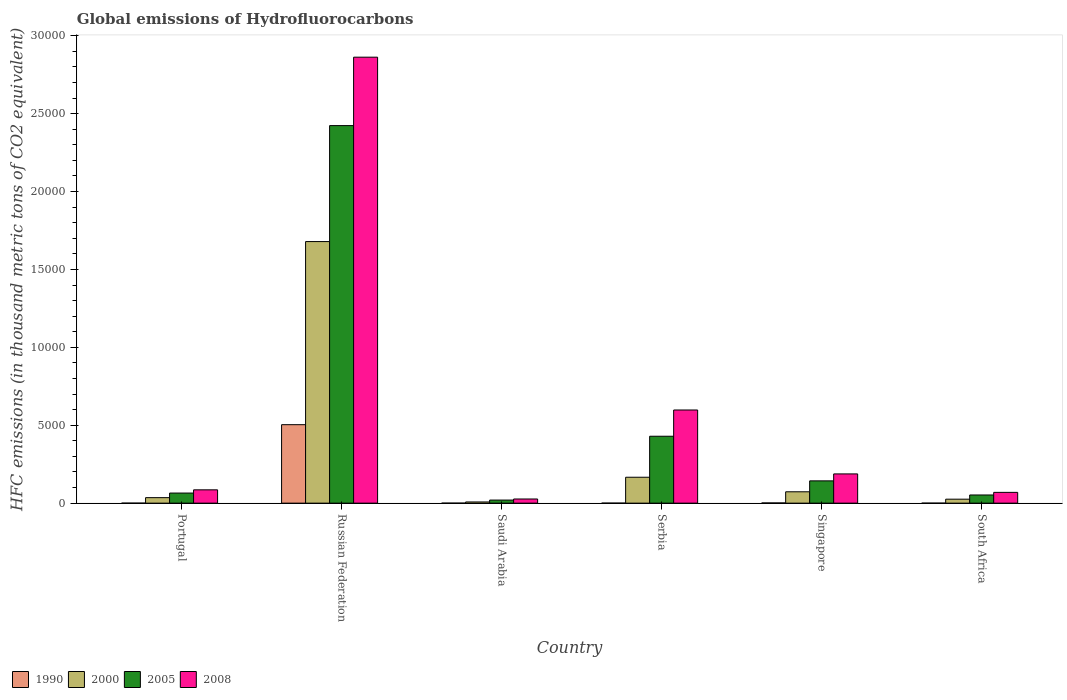Are the number of bars per tick equal to the number of legend labels?
Provide a short and direct response. Yes. How many bars are there on the 6th tick from the right?
Provide a succinct answer. 4. What is the label of the 5th group of bars from the left?
Your response must be concise. Singapore. What is the global emissions of Hydrofluorocarbons in 2000 in Singapore?
Give a very brief answer. 728.9. Across all countries, what is the maximum global emissions of Hydrofluorocarbons in 1990?
Your answer should be compact. 5035.6. Across all countries, what is the minimum global emissions of Hydrofluorocarbons in 2000?
Ensure brevity in your answer.  75.5. In which country was the global emissions of Hydrofluorocarbons in 2005 maximum?
Offer a terse response. Russian Federation. In which country was the global emissions of Hydrofluorocarbons in 2008 minimum?
Make the answer very short. Saudi Arabia. What is the total global emissions of Hydrofluorocarbons in 2000 in the graph?
Your response must be concise. 1.99e+04. What is the difference between the global emissions of Hydrofluorocarbons in 2008 in Portugal and that in Serbia?
Make the answer very short. -5124.6. What is the difference between the global emissions of Hydrofluorocarbons in 1990 in Saudi Arabia and the global emissions of Hydrofluorocarbons in 2000 in Serbia?
Offer a very short reply. -1661.9. What is the average global emissions of Hydrofluorocarbons in 2000 per country?
Ensure brevity in your answer.  3310.4. What is the difference between the global emissions of Hydrofluorocarbons of/in 2005 and global emissions of Hydrofluorocarbons of/in 2000 in Portugal?
Your answer should be very brief. 295. What is the ratio of the global emissions of Hydrofluorocarbons in 2005 in Russian Federation to that in Singapore?
Ensure brevity in your answer.  16.95. Is the difference between the global emissions of Hydrofluorocarbons in 2005 in Saudi Arabia and Serbia greater than the difference between the global emissions of Hydrofluorocarbons in 2000 in Saudi Arabia and Serbia?
Offer a terse response. No. What is the difference between the highest and the second highest global emissions of Hydrofluorocarbons in 2008?
Offer a very short reply. 4102.6. What is the difference between the highest and the lowest global emissions of Hydrofluorocarbons in 2008?
Your response must be concise. 2.84e+04. In how many countries, is the global emissions of Hydrofluorocarbons in 2008 greater than the average global emissions of Hydrofluorocarbons in 2008 taken over all countries?
Your answer should be compact. 1. Is the sum of the global emissions of Hydrofluorocarbons in 2005 in Portugal and Singapore greater than the maximum global emissions of Hydrofluorocarbons in 1990 across all countries?
Provide a short and direct response. No. Is it the case that in every country, the sum of the global emissions of Hydrofluorocarbons in 1990 and global emissions of Hydrofluorocarbons in 2008 is greater than the sum of global emissions of Hydrofluorocarbons in 2005 and global emissions of Hydrofluorocarbons in 2000?
Provide a succinct answer. No. How many bars are there?
Keep it short and to the point. 24. How many countries are there in the graph?
Your response must be concise. 6. What is the difference between two consecutive major ticks on the Y-axis?
Offer a terse response. 5000. How many legend labels are there?
Provide a short and direct response. 4. How are the legend labels stacked?
Keep it short and to the point. Horizontal. What is the title of the graph?
Your answer should be very brief. Global emissions of Hydrofluorocarbons. What is the label or title of the X-axis?
Offer a terse response. Country. What is the label or title of the Y-axis?
Your answer should be compact. HFC emissions (in thousand metric tons of CO2 equivalent). What is the HFC emissions (in thousand metric tons of CO2 equivalent) in 1990 in Portugal?
Offer a very short reply. 0.2. What is the HFC emissions (in thousand metric tons of CO2 equivalent) in 2000 in Portugal?
Keep it short and to the point. 352.7. What is the HFC emissions (in thousand metric tons of CO2 equivalent) in 2005 in Portugal?
Provide a short and direct response. 647.7. What is the HFC emissions (in thousand metric tons of CO2 equivalent) of 2008 in Portugal?
Your response must be concise. 854.4. What is the HFC emissions (in thousand metric tons of CO2 equivalent) in 1990 in Russian Federation?
Offer a terse response. 5035.6. What is the HFC emissions (in thousand metric tons of CO2 equivalent) in 2000 in Russian Federation?
Your response must be concise. 1.68e+04. What is the HFC emissions (in thousand metric tons of CO2 equivalent) in 2005 in Russian Federation?
Your answer should be very brief. 2.42e+04. What is the HFC emissions (in thousand metric tons of CO2 equivalent) in 2008 in Russian Federation?
Give a very brief answer. 2.86e+04. What is the HFC emissions (in thousand metric tons of CO2 equivalent) in 2000 in Saudi Arabia?
Ensure brevity in your answer.  75.5. What is the HFC emissions (in thousand metric tons of CO2 equivalent) of 2005 in Saudi Arabia?
Your response must be concise. 196.9. What is the HFC emissions (in thousand metric tons of CO2 equivalent) in 2008 in Saudi Arabia?
Provide a succinct answer. 266.5. What is the HFC emissions (in thousand metric tons of CO2 equivalent) of 2000 in Serbia?
Your answer should be compact. 1662. What is the HFC emissions (in thousand metric tons of CO2 equivalent) in 2005 in Serbia?
Your response must be concise. 4293.8. What is the HFC emissions (in thousand metric tons of CO2 equivalent) of 2008 in Serbia?
Provide a succinct answer. 5979. What is the HFC emissions (in thousand metric tons of CO2 equivalent) in 2000 in Singapore?
Provide a short and direct response. 728.9. What is the HFC emissions (in thousand metric tons of CO2 equivalent) in 2005 in Singapore?
Your answer should be compact. 1429.7. What is the HFC emissions (in thousand metric tons of CO2 equivalent) of 2008 in Singapore?
Your response must be concise. 1876.4. What is the HFC emissions (in thousand metric tons of CO2 equivalent) in 1990 in South Africa?
Offer a very short reply. 0.2. What is the HFC emissions (in thousand metric tons of CO2 equivalent) in 2000 in South Africa?
Your response must be concise. 254.6. What is the HFC emissions (in thousand metric tons of CO2 equivalent) in 2005 in South Africa?
Ensure brevity in your answer.  524.5. What is the HFC emissions (in thousand metric tons of CO2 equivalent) of 2008 in South Africa?
Provide a succinct answer. 691.6. Across all countries, what is the maximum HFC emissions (in thousand metric tons of CO2 equivalent) in 1990?
Provide a short and direct response. 5035.6. Across all countries, what is the maximum HFC emissions (in thousand metric tons of CO2 equivalent) of 2000?
Offer a terse response. 1.68e+04. Across all countries, what is the maximum HFC emissions (in thousand metric tons of CO2 equivalent) in 2005?
Provide a succinct answer. 2.42e+04. Across all countries, what is the maximum HFC emissions (in thousand metric tons of CO2 equivalent) in 2008?
Your answer should be compact. 2.86e+04. Across all countries, what is the minimum HFC emissions (in thousand metric tons of CO2 equivalent) in 1990?
Provide a succinct answer. 0.1. Across all countries, what is the minimum HFC emissions (in thousand metric tons of CO2 equivalent) in 2000?
Your answer should be compact. 75.5. Across all countries, what is the minimum HFC emissions (in thousand metric tons of CO2 equivalent) in 2005?
Keep it short and to the point. 196.9. Across all countries, what is the minimum HFC emissions (in thousand metric tons of CO2 equivalent) of 2008?
Your answer should be very brief. 266.5. What is the total HFC emissions (in thousand metric tons of CO2 equivalent) of 1990 in the graph?
Provide a succinct answer. 5049.2. What is the total HFC emissions (in thousand metric tons of CO2 equivalent) in 2000 in the graph?
Offer a terse response. 1.99e+04. What is the total HFC emissions (in thousand metric tons of CO2 equivalent) in 2005 in the graph?
Keep it short and to the point. 3.13e+04. What is the total HFC emissions (in thousand metric tons of CO2 equivalent) in 2008 in the graph?
Offer a very short reply. 3.83e+04. What is the difference between the HFC emissions (in thousand metric tons of CO2 equivalent) in 1990 in Portugal and that in Russian Federation?
Provide a succinct answer. -5035.4. What is the difference between the HFC emissions (in thousand metric tons of CO2 equivalent) in 2000 in Portugal and that in Russian Federation?
Provide a short and direct response. -1.64e+04. What is the difference between the HFC emissions (in thousand metric tons of CO2 equivalent) in 2005 in Portugal and that in Russian Federation?
Give a very brief answer. -2.36e+04. What is the difference between the HFC emissions (in thousand metric tons of CO2 equivalent) in 2008 in Portugal and that in Russian Federation?
Ensure brevity in your answer.  -2.78e+04. What is the difference between the HFC emissions (in thousand metric tons of CO2 equivalent) of 1990 in Portugal and that in Saudi Arabia?
Provide a short and direct response. 0.1. What is the difference between the HFC emissions (in thousand metric tons of CO2 equivalent) of 2000 in Portugal and that in Saudi Arabia?
Provide a short and direct response. 277.2. What is the difference between the HFC emissions (in thousand metric tons of CO2 equivalent) in 2005 in Portugal and that in Saudi Arabia?
Offer a terse response. 450.8. What is the difference between the HFC emissions (in thousand metric tons of CO2 equivalent) of 2008 in Portugal and that in Saudi Arabia?
Offer a terse response. 587.9. What is the difference between the HFC emissions (in thousand metric tons of CO2 equivalent) of 2000 in Portugal and that in Serbia?
Ensure brevity in your answer.  -1309.3. What is the difference between the HFC emissions (in thousand metric tons of CO2 equivalent) in 2005 in Portugal and that in Serbia?
Ensure brevity in your answer.  -3646.1. What is the difference between the HFC emissions (in thousand metric tons of CO2 equivalent) of 2008 in Portugal and that in Serbia?
Provide a short and direct response. -5124.6. What is the difference between the HFC emissions (in thousand metric tons of CO2 equivalent) of 2000 in Portugal and that in Singapore?
Provide a succinct answer. -376.2. What is the difference between the HFC emissions (in thousand metric tons of CO2 equivalent) in 2005 in Portugal and that in Singapore?
Give a very brief answer. -782. What is the difference between the HFC emissions (in thousand metric tons of CO2 equivalent) in 2008 in Portugal and that in Singapore?
Provide a succinct answer. -1022. What is the difference between the HFC emissions (in thousand metric tons of CO2 equivalent) in 2000 in Portugal and that in South Africa?
Your answer should be compact. 98.1. What is the difference between the HFC emissions (in thousand metric tons of CO2 equivalent) of 2005 in Portugal and that in South Africa?
Offer a very short reply. 123.2. What is the difference between the HFC emissions (in thousand metric tons of CO2 equivalent) of 2008 in Portugal and that in South Africa?
Ensure brevity in your answer.  162.8. What is the difference between the HFC emissions (in thousand metric tons of CO2 equivalent) of 1990 in Russian Federation and that in Saudi Arabia?
Your answer should be very brief. 5035.5. What is the difference between the HFC emissions (in thousand metric tons of CO2 equivalent) of 2000 in Russian Federation and that in Saudi Arabia?
Make the answer very short. 1.67e+04. What is the difference between the HFC emissions (in thousand metric tons of CO2 equivalent) of 2005 in Russian Federation and that in Saudi Arabia?
Make the answer very short. 2.40e+04. What is the difference between the HFC emissions (in thousand metric tons of CO2 equivalent) in 2008 in Russian Federation and that in Saudi Arabia?
Ensure brevity in your answer.  2.84e+04. What is the difference between the HFC emissions (in thousand metric tons of CO2 equivalent) of 1990 in Russian Federation and that in Serbia?
Make the answer very short. 5035.1. What is the difference between the HFC emissions (in thousand metric tons of CO2 equivalent) of 2000 in Russian Federation and that in Serbia?
Your answer should be very brief. 1.51e+04. What is the difference between the HFC emissions (in thousand metric tons of CO2 equivalent) in 2005 in Russian Federation and that in Serbia?
Your answer should be compact. 1.99e+04. What is the difference between the HFC emissions (in thousand metric tons of CO2 equivalent) in 2008 in Russian Federation and that in Serbia?
Your answer should be very brief. 2.26e+04. What is the difference between the HFC emissions (in thousand metric tons of CO2 equivalent) of 1990 in Russian Federation and that in Singapore?
Make the answer very short. 5023. What is the difference between the HFC emissions (in thousand metric tons of CO2 equivalent) in 2000 in Russian Federation and that in Singapore?
Offer a very short reply. 1.61e+04. What is the difference between the HFC emissions (in thousand metric tons of CO2 equivalent) in 2005 in Russian Federation and that in Singapore?
Your response must be concise. 2.28e+04. What is the difference between the HFC emissions (in thousand metric tons of CO2 equivalent) in 2008 in Russian Federation and that in Singapore?
Ensure brevity in your answer.  2.67e+04. What is the difference between the HFC emissions (in thousand metric tons of CO2 equivalent) of 1990 in Russian Federation and that in South Africa?
Your answer should be very brief. 5035.4. What is the difference between the HFC emissions (in thousand metric tons of CO2 equivalent) in 2000 in Russian Federation and that in South Africa?
Keep it short and to the point. 1.65e+04. What is the difference between the HFC emissions (in thousand metric tons of CO2 equivalent) in 2005 in Russian Federation and that in South Africa?
Your answer should be very brief. 2.37e+04. What is the difference between the HFC emissions (in thousand metric tons of CO2 equivalent) in 2008 in Russian Federation and that in South Africa?
Offer a terse response. 2.79e+04. What is the difference between the HFC emissions (in thousand metric tons of CO2 equivalent) in 1990 in Saudi Arabia and that in Serbia?
Provide a short and direct response. -0.4. What is the difference between the HFC emissions (in thousand metric tons of CO2 equivalent) in 2000 in Saudi Arabia and that in Serbia?
Give a very brief answer. -1586.5. What is the difference between the HFC emissions (in thousand metric tons of CO2 equivalent) in 2005 in Saudi Arabia and that in Serbia?
Offer a terse response. -4096.9. What is the difference between the HFC emissions (in thousand metric tons of CO2 equivalent) in 2008 in Saudi Arabia and that in Serbia?
Offer a terse response. -5712.5. What is the difference between the HFC emissions (in thousand metric tons of CO2 equivalent) in 1990 in Saudi Arabia and that in Singapore?
Keep it short and to the point. -12.5. What is the difference between the HFC emissions (in thousand metric tons of CO2 equivalent) of 2000 in Saudi Arabia and that in Singapore?
Your answer should be very brief. -653.4. What is the difference between the HFC emissions (in thousand metric tons of CO2 equivalent) in 2005 in Saudi Arabia and that in Singapore?
Ensure brevity in your answer.  -1232.8. What is the difference between the HFC emissions (in thousand metric tons of CO2 equivalent) in 2008 in Saudi Arabia and that in Singapore?
Offer a very short reply. -1609.9. What is the difference between the HFC emissions (in thousand metric tons of CO2 equivalent) in 1990 in Saudi Arabia and that in South Africa?
Your answer should be compact. -0.1. What is the difference between the HFC emissions (in thousand metric tons of CO2 equivalent) in 2000 in Saudi Arabia and that in South Africa?
Offer a very short reply. -179.1. What is the difference between the HFC emissions (in thousand metric tons of CO2 equivalent) of 2005 in Saudi Arabia and that in South Africa?
Offer a terse response. -327.6. What is the difference between the HFC emissions (in thousand metric tons of CO2 equivalent) in 2008 in Saudi Arabia and that in South Africa?
Ensure brevity in your answer.  -425.1. What is the difference between the HFC emissions (in thousand metric tons of CO2 equivalent) of 1990 in Serbia and that in Singapore?
Ensure brevity in your answer.  -12.1. What is the difference between the HFC emissions (in thousand metric tons of CO2 equivalent) of 2000 in Serbia and that in Singapore?
Your answer should be compact. 933.1. What is the difference between the HFC emissions (in thousand metric tons of CO2 equivalent) of 2005 in Serbia and that in Singapore?
Give a very brief answer. 2864.1. What is the difference between the HFC emissions (in thousand metric tons of CO2 equivalent) of 2008 in Serbia and that in Singapore?
Your answer should be compact. 4102.6. What is the difference between the HFC emissions (in thousand metric tons of CO2 equivalent) in 2000 in Serbia and that in South Africa?
Make the answer very short. 1407.4. What is the difference between the HFC emissions (in thousand metric tons of CO2 equivalent) in 2005 in Serbia and that in South Africa?
Your answer should be very brief. 3769.3. What is the difference between the HFC emissions (in thousand metric tons of CO2 equivalent) in 2008 in Serbia and that in South Africa?
Ensure brevity in your answer.  5287.4. What is the difference between the HFC emissions (in thousand metric tons of CO2 equivalent) of 2000 in Singapore and that in South Africa?
Offer a very short reply. 474.3. What is the difference between the HFC emissions (in thousand metric tons of CO2 equivalent) of 2005 in Singapore and that in South Africa?
Your response must be concise. 905.2. What is the difference between the HFC emissions (in thousand metric tons of CO2 equivalent) in 2008 in Singapore and that in South Africa?
Your answer should be very brief. 1184.8. What is the difference between the HFC emissions (in thousand metric tons of CO2 equivalent) of 1990 in Portugal and the HFC emissions (in thousand metric tons of CO2 equivalent) of 2000 in Russian Federation?
Your response must be concise. -1.68e+04. What is the difference between the HFC emissions (in thousand metric tons of CO2 equivalent) of 1990 in Portugal and the HFC emissions (in thousand metric tons of CO2 equivalent) of 2005 in Russian Federation?
Ensure brevity in your answer.  -2.42e+04. What is the difference between the HFC emissions (in thousand metric tons of CO2 equivalent) in 1990 in Portugal and the HFC emissions (in thousand metric tons of CO2 equivalent) in 2008 in Russian Federation?
Your response must be concise. -2.86e+04. What is the difference between the HFC emissions (in thousand metric tons of CO2 equivalent) of 2000 in Portugal and the HFC emissions (in thousand metric tons of CO2 equivalent) of 2005 in Russian Federation?
Give a very brief answer. -2.39e+04. What is the difference between the HFC emissions (in thousand metric tons of CO2 equivalent) of 2000 in Portugal and the HFC emissions (in thousand metric tons of CO2 equivalent) of 2008 in Russian Federation?
Your response must be concise. -2.83e+04. What is the difference between the HFC emissions (in thousand metric tons of CO2 equivalent) of 2005 in Portugal and the HFC emissions (in thousand metric tons of CO2 equivalent) of 2008 in Russian Federation?
Ensure brevity in your answer.  -2.80e+04. What is the difference between the HFC emissions (in thousand metric tons of CO2 equivalent) in 1990 in Portugal and the HFC emissions (in thousand metric tons of CO2 equivalent) in 2000 in Saudi Arabia?
Provide a succinct answer. -75.3. What is the difference between the HFC emissions (in thousand metric tons of CO2 equivalent) of 1990 in Portugal and the HFC emissions (in thousand metric tons of CO2 equivalent) of 2005 in Saudi Arabia?
Your answer should be compact. -196.7. What is the difference between the HFC emissions (in thousand metric tons of CO2 equivalent) of 1990 in Portugal and the HFC emissions (in thousand metric tons of CO2 equivalent) of 2008 in Saudi Arabia?
Provide a succinct answer. -266.3. What is the difference between the HFC emissions (in thousand metric tons of CO2 equivalent) of 2000 in Portugal and the HFC emissions (in thousand metric tons of CO2 equivalent) of 2005 in Saudi Arabia?
Offer a terse response. 155.8. What is the difference between the HFC emissions (in thousand metric tons of CO2 equivalent) in 2000 in Portugal and the HFC emissions (in thousand metric tons of CO2 equivalent) in 2008 in Saudi Arabia?
Provide a succinct answer. 86.2. What is the difference between the HFC emissions (in thousand metric tons of CO2 equivalent) of 2005 in Portugal and the HFC emissions (in thousand metric tons of CO2 equivalent) of 2008 in Saudi Arabia?
Make the answer very short. 381.2. What is the difference between the HFC emissions (in thousand metric tons of CO2 equivalent) of 1990 in Portugal and the HFC emissions (in thousand metric tons of CO2 equivalent) of 2000 in Serbia?
Your answer should be compact. -1661.8. What is the difference between the HFC emissions (in thousand metric tons of CO2 equivalent) in 1990 in Portugal and the HFC emissions (in thousand metric tons of CO2 equivalent) in 2005 in Serbia?
Your answer should be very brief. -4293.6. What is the difference between the HFC emissions (in thousand metric tons of CO2 equivalent) of 1990 in Portugal and the HFC emissions (in thousand metric tons of CO2 equivalent) of 2008 in Serbia?
Offer a terse response. -5978.8. What is the difference between the HFC emissions (in thousand metric tons of CO2 equivalent) in 2000 in Portugal and the HFC emissions (in thousand metric tons of CO2 equivalent) in 2005 in Serbia?
Provide a succinct answer. -3941.1. What is the difference between the HFC emissions (in thousand metric tons of CO2 equivalent) in 2000 in Portugal and the HFC emissions (in thousand metric tons of CO2 equivalent) in 2008 in Serbia?
Your answer should be compact. -5626.3. What is the difference between the HFC emissions (in thousand metric tons of CO2 equivalent) in 2005 in Portugal and the HFC emissions (in thousand metric tons of CO2 equivalent) in 2008 in Serbia?
Provide a short and direct response. -5331.3. What is the difference between the HFC emissions (in thousand metric tons of CO2 equivalent) in 1990 in Portugal and the HFC emissions (in thousand metric tons of CO2 equivalent) in 2000 in Singapore?
Offer a terse response. -728.7. What is the difference between the HFC emissions (in thousand metric tons of CO2 equivalent) in 1990 in Portugal and the HFC emissions (in thousand metric tons of CO2 equivalent) in 2005 in Singapore?
Offer a very short reply. -1429.5. What is the difference between the HFC emissions (in thousand metric tons of CO2 equivalent) in 1990 in Portugal and the HFC emissions (in thousand metric tons of CO2 equivalent) in 2008 in Singapore?
Your answer should be compact. -1876.2. What is the difference between the HFC emissions (in thousand metric tons of CO2 equivalent) of 2000 in Portugal and the HFC emissions (in thousand metric tons of CO2 equivalent) of 2005 in Singapore?
Your response must be concise. -1077. What is the difference between the HFC emissions (in thousand metric tons of CO2 equivalent) of 2000 in Portugal and the HFC emissions (in thousand metric tons of CO2 equivalent) of 2008 in Singapore?
Give a very brief answer. -1523.7. What is the difference between the HFC emissions (in thousand metric tons of CO2 equivalent) in 2005 in Portugal and the HFC emissions (in thousand metric tons of CO2 equivalent) in 2008 in Singapore?
Provide a succinct answer. -1228.7. What is the difference between the HFC emissions (in thousand metric tons of CO2 equivalent) of 1990 in Portugal and the HFC emissions (in thousand metric tons of CO2 equivalent) of 2000 in South Africa?
Your answer should be very brief. -254.4. What is the difference between the HFC emissions (in thousand metric tons of CO2 equivalent) of 1990 in Portugal and the HFC emissions (in thousand metric tons of CO2 equivalent) of 2005 in South Africa?
Provide a succinct answer. -524.3. What is the difference between the HFC emissions (in thousand metric tons of CO2 equivalent) of 1990 in Portugal and the HFC emissions (in thousand metric tons of CO2 equivalent) of 2008 in South Africa?
Offer a terse response. -691.4. What is the difference between the HFC emissions (in thousand metric tons of CO2 equivalent) in 2000 in Portugal and the HFC emissions (in thousand metric tons of CO2 equivalent) in 2005 in South Africa?
Your answer should be compact. -171.8. What is the difference between the HFC emissions (in thousand metric tons of CO2 equivalent) in 2000 in Portugal and the HFC emissions (in thousand metric tons of CO2 equivalent) in 2008 in South Africa?
Your answer should be compact. -338.9. What is the difference between the HFC emissions (in thousand metric tons of CO2 equivalent) of 2005 in Portugal and the HFC emissions (in thousand metric tons of CO2 equivalent) of 2008 in South Africa?
Your response must be concise. -43.9. What is the difference between the HFC emissions (in thousand metric tons of CO2 equivalent) of 1990 in Russian Federation and the HFC emissions (in thousand metric tons of CO2 equivalent) of 2000 in Saudi Arabia?
Provide a short and direct response. 4960.1. What is the difference between the HFC emissions (in thousand metric tons of CO2 equivalent) of 1990 in Russian Federation and the HFC emissions (in thousand metric tons of CO2 equivalent) of 2005 in Saudi Arabia?
Your answer should be compact. 4838.7. What is the difference between the HFC emissions (in thousand metric tons of CO2 equivalent) of 1990 in Russian Federation and the HFC emissions (in thousand metric tons of CO2 equivalent) of 2008 in Saudi Arabia?
Provide a short and direct response. 4769.1. What is the difference between the HFC emissions (in thousand metric tons of CO2 equivalent) of 2000 in Russian Federation and the HFC emissions (in thousand metric tons of CO2 equivalent) of 2005 in Saudi Arabia?
Provide a short and direct response. 1.66e+04. What is the difference between the HFC emissions (in thousand metric tons of CO2 equivalent) of 2000 in Russian Federation and the HFC emissions (in thousand metric tons of CO2 equivalent) of 2008 in Saudi Arabia?
Your answer should be compact. 1.65e+04. What is the difference between the HFC emissions (in thousand metric tons of CO2 equivalent) of 2005 in Russian Federation and the HFC emissions (in thousand metric tons of CO2 equivalent) of 2008 in Saudi Arabia?
Make the answer very short. 2.40e+04. What is the difference between the HFC emissions (in thousand metric tons of CO2 equivalent) in 1990 in Russian Federation and the HFC emissions (in thousand metric tons of CO2 equivalent) in 2000 in Serbia?
Your answer should be very brief. 3373.6. What is the difference between the HFC emissions (in thousand metric tons of CO2 equivalent) of 1990 in Russian Federation and the HFC emissions (in thousand metric tons of CO2 equivalent) of 2005 in Serbia?
Make the answer very short. 741.8. What is the difference between the HFC emissions (in thousand metric tons of CO2 equivalent) of 1990 in Russian Federation and the HFC emissions (in thousand metric tons of CO2 equivalent) of 2008 in Serbia?
Your answer should be very brief. -943.4. What is the difference between the HFC emissions (in thousand metric tons of CO2 equivalent) in 2000 in Russian Federation and the HFC emissions (in thousand metric tons of CO2 equivalent) in 2005 in Serbia?
Make the answer very short. 1.25e+04. What is the difference between the HFC emissions (in thousand metric tons of CO2 equivalent) of 2000 in Russian Federation and the HFC emissions (in thousand metric tons of CO2 equivalent) of 2008 in Serbia?
Offer a very short reply. 1.08e+04. What is the difference between the HFC emissions (in thousand metric tons of CO2 equivalent) in 2005 in Russian Federation and the HFC emissions (in thousand metric tons of CO2 equivalent) in 2008 in Serbia?
Your answer should be compact. 1.83e+04. What is the difference between the HFC emissions (in thousand metric tons of CO2 equivalent) of 1990 in Russian Federation and the HFC emissions (in thousand metric tons of CO2 equivalent) of 2000 in Singapore?
Offer a very short reply. 4306.7. What is the difference between the HFC emissions (in thousand metric tons of CO2 equivalent) in 1990 in Russian Federation and the HFC emissions (in thousand metric tons of CO2 equivalent) in 2005 in Singapore?
Ensure brevity in your answer.  3605.9. What is the difference between the HFC emissions (in thousand metric tons of CO2 equivalent) of 1990 in Russian Federation and the HFC emissions (in thousand metric tons of CO2 equivalent) of 2008 in Singapore?
Provide a succinct answer. 3159.2. What is the difference between the HFC emissions (in thousand metric tons of CO2 equivalent) of 2000 in Russian Federation and the HFC emissions (in thousand metric tons of CO2 equivalent) of 2005 in Singapore?
Give a very brief answer. 1.54e+04. What is the difference between the HFC emissions (in thousand metric tons of CO2 equivalent) in 2000 in Russian Federation and the HFC emissions (in thousand metric tons of CO2 equivalent) in 2008 in Singapore?
Your answer should be compact. 1.49e+04. What is the difference between the HFC emissions (in thousand metric tons of CO2 equivalent) in 2005 in Russian Federation and the HFC emissions (in thousand metric tons of CO2 equivalent) in 2008 in Singapore?
Give a very brief answer. 2.24e+04. What is the difference between the HFC emissions (in thousand metric tons of CO2 equivalent) in 1990 in Russian Federation and the HFC emissions (in thousand metric tons of CO2 equivalent) in 2000 in South Africa?
Your response must be concise. 4781. What is the difference between the HFC emissions (in thousand metric tons of CO2 equivalent) of 1990 in Russian Federation and the HFC emissions (in thousand metric tons of CO2 equivalent) of 2005 in South Africa?
Make the answer very short. 4511.1. What is the difference between the HFC emissions (in thousand metric tons of CO2 equivalent) in 1990 in Russian Federation and the HFC emissions (in thousand metric tons of CO2 equivalent) in 2008 in South Africa?
Your answer should be compact. 4344. What is the difference between the HFC emissions (in thousand metric tons of CO2 equivalent) in 2000 in Russian Federation and the HFC emissions (in thousand metric tons of CO2 equivalent) in 2005 in South Africa?
Make the answer very short. 1.63e+04. What is the difference between the HFC emissions (in thousand metric tons of CO2 equivalent) of 2000 in Russian Federation and the HFC emissions (in thousand metric tons of CO2 equivalent) of 2008 in South Africa?
Offer a terse response. 1.61e+04. What is the difference between the HFC emissions (in thousand metric tons of CO2 equivalent) in 2005 in Russian Federation and the HFC emissions (in thousand metric tons of CO2 equivalent) in 2008 in South Africa?
Provide a short and direct response. 2.35e+04. What is the difference between the HFC emissions (in thousand metric tons of CO2 equivalent) in 1990 in Saudi Arabia and the HFC emissions (in thousand metric tons of CO2 equivalent) in 2000 in Serbia?
Provide a succinct answer. -1661.9. What is the difference between the HFC emissions (in thousand metric tons of CO2 equivalent) of 1990 in Saudi Arabia and the HFC emissions (in thousand metric tons of CO2 equivalent) of 2005 in Serbia?
Your answer should be very brief. -4293.7. What is the difference between the HFC emissions (in thousand metric tons of CO2 equivalent) in 1990 in Saudi Arabia and the HFC emissions (in thousand metric tons of CO2 equivalent) in 2008 in Serbia?
Make the answer very short. -5978.9. What is the difference between the HFC emissions (in thousand metric tons of CO2 equivalent) of 2000 in Saudi Arabia and the HFC emissions (in thousand metric tons of CO2 equivalent) of 2005 in Serbia?
Provide a succinct answer. -4218.3. What is the difference between the HFC emissions (in thousand metric tons of CO2 equivalent) of 2000 in Saudi Arabia and the HFC emissions (in thousand metric tons of CO2 equivalent) of 2008 in Serbia?
Offer a terse response. -5903.5. What is the difference between the HFC emissions (in thousand metric tons of CO2 equivalent) in 2005 in Saudi Arabia and the HFC emissions (in thousand metric tons of CO2 equivalent) in 2008 in Serbia?
Make the answer very short. -5782.1. What is the difference between the HFC emissions (in thousand metric tons of CO2 equivalent) of 1990 in Saudi Arabia and the HFC emissions (in thousand metric tons of CO2 equivalent) of 2000 in Singapore?
Ensure brevity in your answer.  -728.8. What is the difference between the HFC emissions (in thousand metric tons of CO2 equivalent) of 1990 in Saudi Arabia and the HFC emissions (in thousand metric tons of CO2 equivalent) of 2005 in Singapore?
Keep it short and to the point. -1429.6. What is the difference between the HFC emissions (in thousand metric tons of CO2 equivalent) of 1990 in Saudi Arabia and the HFC emissions (in thousand metric tons of CO2 equivalent) of 2008 in Singapore?
Give a very brief answer. -1876.3. What is the difference between the HFC emissions (in thousand metric tons of CO2 equivalent) in 2000 in Saudi Arabia and the HFC emissions (in thousand metric tons of CO2 equivalent) in 2005 in Singapore?
Ensure brevity in your answer.  -1354.2. What is the difference between the HFC emissions (in thousand metric tons of CO2 equivalent) of 2000 in Saudi Arabia and the HFC emissions (in thousand metric tons of CO2 equivalent) of 2008 in Singapore?
Your response must be concise. -1800.9. What is the difference between the HFC emissions (in thousand metric tons of CO2 equivalent) in 2005 in Saudi Arabia and the HFC emissions (in thousand metric tons of CO2 equivalent) in 2008 in Singapore?
Keep it short and to the point. -1679.5. What is the difference between the HFC emissions (in thousand metric tons of CO2 equivalent) of 1990 in Saudi Arabia and the HFC emissions (in thousand metric tons of CO2 equivalent) of 2000 in South Africa?
Ensure brevity in your answer.  -254.5. What is the difference between the HFC emissions (in thousand metric tons of CO2 equivalent) of 1990 in Saudi Arabia and the HFC emissions (in thousand metric tons of CO2 equivalent) of 2005 in South Africa?
Your response must be concise. -524.4. What is the difference between the HFC emissions (in thousand metric tons of CO2 equivalent) of 1990 in Saudi Arabia and the HFC emissions (in thousand metric tons of CO2 equivalent) of 2008 in South Africa?
Ensure brevity in your answer.  -691.5. What is the difference between the HFC emissions (in thousand metric tons of CO2 equivalent) of 2000 in Saudi Arabia and the HFC emissions (in thousand metric tons of CO2 equivalent) of 2005 in South Africa?
Give a very brief answer. -449. What is the difference between the HFC emissions (in thousand metric tons of CO2 equivalent) in 2000 in Saudi Arabia and the HFC emissions (in thousand metric tons of CO2 equivalent) in 2008 in South Africa?
Your response must be concise. -616.1. What is the difference between the HFC emissions (in thousand metric tons of CO2 equivalent) in 2005 in Saudi Arabia and the HFC emissions (in thousand metric tons of CO2 equivalent) in 2008 in South Africa?
Give a very brief answer. -494.7. What is the difference between the HFC emissions (in thousand metric tons of CO2 equivalent) in 1990 in Serbia and the HFC emissions (in thousand metric tons of CO2 equivalent) in 2000 in Singapore?
Your answer should be very brief. -728.4. What is the difference between the HFC emissions (in thousand metric tons of CO2 equivalent) in 1990 in Serbia and the HFC emissions (in thousand metric tons of CO2 equivalent) in 2005 in Singapore?
Make the answer very short. -1429.2. What is the difference between the HFC emissions (in thousand metric tons of CO2 equivalent) of 1990 in Serbia and the HFC emissions (in thousand metric tons of CO2 equivalent) of 2008 in Singapore?
Give a very brief answer. -1875.9. What is the difference between the HFC emissions (in thousand metric tons of CO2 equivalent) in 2000 in Serbia and the HFC emissions (in thousand metric tons of CO2 equivalent) in 2005 in Singapore?
Offer a terse response. 232.3. What is the difference between the HFC emissions (in thousand metric tons of CO2 equivalent) in 2000 in Serbia and the HFC emissions (in thousand metric tons of CO2 equivalent) in 2008 in Singapore?
Ensure brevity in your answer.  -214.4. What is the difference between the HFC emissions (in thousand metric tons of CO2 equivalent) of 2005 in Serbia and the HFC emissions (in thousand metric tons of CO2 equivalent) of 2008 in Singapore?
Offer a terse response. 2417.4. What is the difference between the HFC emissions (in thousand metric tons of CO2 equivalent) in 1990 in Serbia and the HFC emissions (in thousand metric tons of CO2 equivalent) in 2000 in South Africa?
Give a very brief answer. -254.1. What is the difference between the HFC emissions (in thousand metric tons of CO2 equivalent) in 1990 in Serbia and the HFC emissions (in thousand metric tons of CO2 equivalent) in 2005 in South Africa?
Give a very brief answer. -524. What is the difference between the HFC emissions (in thousand metric tons of CO2 equivalent) in 1990 in Serbia and the HFC emissions (in thousand metric tons of CO2 equivalent) in 2008 in South Africa?
Your answer should be very brief. -691.1. What is the difference between the HFC emissions (in thousand metric tons of CO2 equivalent) in 2000 in Serbia and the HFC emissions (in thousand metric tons of CO2 equivalent) in 2005 in South Africa?
Provide a succinct answer. 1137.5. What is the difference between the HFC emissions (in thousand metric tons of CO2 equivalent) of 2000 in Serbia and the HFC emissions (in thousand metric tons of CO2 equivalent) of 2008 in South Africa?
Offer a terse response. 970.4. What is the difference between the HFC emissions (in thousand metric tons of CO2 equivalent) in 2005 in Serbia and the HFC emissions (in thousand metric tons of CO2 equivalent) in 2008 in South Africa?
Provide a short and direct response. 3602.2. What is the difference between the HFC emissions (in thousand metric tons of CO2 equivalent) of 1990 in Singapore and the HFC emissions (in thousand metric tons of CO2 equivalent) of 2000 in South Africa?
Your response must be concise. -242. What is the difference between the HFC emissions (in thousand metric tons of CO2 equivalent) in 1990 in Singapore and the HFC emissions (in thousand metric tons of CO2 equivalent) in 2005 in South Africa?
Your answer should be compact. -511.9. What is the difference between the HFC emissions (in thousand metric tons of CO2 equivalent) of 1990 in Singapore and the HFC emissions (in thousand metric tons of CO2 equivalent) of 2008 in South Africa?
Your response must be concise. -679. What is the difference between the HFC emissions (in thousand metric tons of CO2 equivalent) in 2000 in Singapore and the HFC emissions (in thousand metric tons of CO2 equivalent) in 2005 in South Africa?
Your answer should be very brief. 204.4. What is the difference between the HFC emissions (in thousand metric tons of CO2 equivalent) in 2000 in Singapore and the HFC emissions (in thousand metric tons of CO2 equivalent) in 2008 in South Africa?
Give a very brief answer. 37.3. What is the difference between the HFC emissions (in thousand metric tons of CO2 equivalent) in 2005 in Singapore and the HFC emissions (in thousand metric tons of CO2 equivalent) in 2008 in South Africa?
Provide a succinct answer. 738.1. What is the average HFC emissions (in thousand metric tons of CO2 equivalent) in 1990 per country?
Provide a short and direct response. 841.53. What is the average HFC emissions (in thousand metric tons of CO2 equivalent) in 2000 per country?
Ensure brevity in your answer.  3310.4. What is the average HFC emissions (in thousand metric tons of CO2 equivalent) of 2005 per country?
Offer a terse response. 5220.65. What is the average HFC emissions (in thousand metric tons of CO2 equivalent) in 2008 per country?
Give a very brief answer. 6381.9. What is the difference between the HFC emissions (in thousand metric tons of CO2 equivalent) of 1990 and HFC emissions (in thousand metric tons of CO2 equivalent) of 2000 in Portugal?
Your response must be concise. -352.5. What is the difference between the HFC emissions (in thousand metric tons of CO2 equivalent) in 1990 and HFC emissions (in thousand metric tons of CO2 equivalent) in 2005 in Portugal?
Keep it short and to the point. -647.5. What is the difference between the HFC emissions (in thousand metric tons of CO2 equivalent) in 1990 and HFC emissions (in thousand metric tons of CO2 equivalent) in 2008 in Portugal?
Offer a terse response. -854.2. What is the difference between the HFC emissions (in thousand metric tons of CO2 equivalent) in 2000 and HFC emissions (in thousand metric tons of CO2 equivalent) in 2005 in Portugal?
Offer a terse response. -295. What is the difference between the HFC emissions (in thousand metric tons of CO2 equivalent) of 2000 and HFC emissions (in thousand metric tons of CO2 equivalent) of 2008 in Portugal?
Your answer should be very brief. -501.7. What is the difference between the HFC emissions (in thousand metric tons of CO2 equivalent) in 2005 and HFC emissions (in thousand metric tons of CO2 equivalent) in 2008 in Portugal?
Ensure brevity in your answer.  -206.7. What is the difference between the HFC emissions (in thousand metric tons of CO2 equivalent) in 1990 and HFC emissions (in thousand metric tons of CO2 equivalent) in 2000 in Russian Federation?
Your answer should be compact. -1.18e+04. What is the difference between the HFC emissions (in thousand metric tons of CO2 equivalent) in 1990 and HFC emissions (in thousand metric tons of CO2 equivalent) in 2005 in Russian Federation?
Keep it short and to the point. -1.92e+04. What is the difference between the HFC emissions (in thousand metric tons of CO2 equivalent) in 1990 and HFC emissions (in thousand metric tons of CO2 equivalent) in 2008 in Russian Federation?
Offer a terse response. -2.36e+04. What is the difference between the HFC emissions (in thousand metric tons of CO2 equivalent) in 2000 and HFC emissions (in thousand metric tons of CO2 equivalent) in 2005 in Russian Federation?
Make the answer very short. -7442.6. What is the difference between the HFC emissions (in thousand metric tons of CO2 equivalent) of 2000 and HFC emissions (in thousand metric tons of CO2 equivalent) of 2008 in Russian Federation?
Keep it short and to the point. -1.18e+04. What is the difference between the HFC emissions (in thousand metric tons of CO2 equivalent) of 2005 and HFC emissions (in thousand metric tons of CO2 equivalent) of 2008 in Russian Federation?
Your response must be concise. -4392.2. What is the difference between the HFC emissions (in thousand metric tons of CO2 equivalent) of 1990 and HFC emissions (in thousand metric tons of CO2 equivalent) of 2000 in Saudi Arabia?
Give a very brief answer. -75.4. What is the difference between the HFC emissions (in thousand metric tons of CO2 equivalent) in 1990 and HFC emissions (in thousand metric tons of CO2 equivalent) in 2005 in Saudi Arabia?
Provide a succinct answer. -196.8. What is the difference between the HFC emissions (in thousand metric tons of CO2 equivalent) in 1990 and HFC emissions (in thousand metric tons of CO2 equivalent) in 2008 in Saudi Arabia?
Make the answer very short. -266.4. What is the difference between the HFC emissions (in thousand metric tons of CO2 equivalent) in 2000 and HFC emissions (in thousand metric tons of CO2 equivalent) in 2005 in Saudi Arabia?
Offer a very short reply. -121.4. What is the difference between the HFC emissions (in thousand metric tons of CO2 equivalent) in 2000 and HFC emissions (in thousand metric tons of CO2 equivalent) in 2008 in Saudi Arabia?
Make the answer very short. -191. What is the difference between the HFC emissions (in thousand metric tons of CO2 equivalent) of 2005 and HFC emissions (in thousand metric tons of CO2 equivalent) of 2008 in Saudi Arabia?
Offer a very short reply. -69.6. What is the difference between the HFC emissions (in thousand metric tons of CO2 equivalent) in 1990 and HFC emissions (in thousand metric tons of CO2 equivalent) in 2000 in Serbia?
Keep it short and to the point. -1661.5. What is the difference between the HFC emissions (in thousand metric tons of CO2 equivalent) in 1990 and HFC emissions (in thousand metric tons of CO2 equivalent) in 2005 in Serbia?
Make the answer very short. -4293.3. What is the difference between the HFC emissions (in thousand metric tons of CO2 equivalent) of 1990 and HFC emissions (in thousand metric tons of CO2 equivalent) of 2008 in Serbia?
Your answer should be compact. -5978.5. What is the difference between the HFC emissions (in thousand metric tons of CO2 equivalent) in 2000 and HFC emissions (in thousand metric tons of CO2 equivalent) in 2005 in Serbia?
Offer a terse response. -2631.8. What is the difference between the HFC emissions (in thousand metric tons of CO2 equivalent) of 2000 and HFC emissions (in thousand metric tons of CO2 equivalent) of 2008 in Serbia?
Make the answer very short. -4317. What is the difference between the HFC emissions (in thousand metric tons of CO2 equivalent) in 2005 and HFC emissions (in thousand metric tons of CO2 equivalent) in 2008 in Serbia?
Ensure brevity in your answer.  -1685.2. What is the difference between the HFC emissions (in thousand metric tons of CO2 equivalent) in 1990 and HFC emissions (in thousand metric tons of CO2 equivalent) in 2000 in Singapore?
Your response must be concise. -716.3. What is the difference between the HFC emissions (in thousand metric tons of CO2 equivalent) of 1990 and HFC emissions (in thousand metric tons of CO2 equivalent) of 2005 in Singapore?
Provide a succinct answer. -1417.1. What is the difference between the HFC emissions (in thousand metric tons of CO2 equivalent) of 1990 and HFC emissions (in thousand metric tons of CO2 equivalent) of 2008 in Singapore?
Provide a succinct answer. -1863.8. What is the difference between the HFC emissions (in thousand metric tons of CO2 equivalent) in 2000 and HFC emissions (in thousand metric tons of CO2 equivalent) in 2005 in Singapore?
Your response must be concise. -700.8. What is the difference between the HFC emissions (in thousand metric tons of CO2 equivalent) of 2000 and HFC emissions (in thousand metric tons of CO2 equivalent) of 2008 in Singapore?
Your answer should be very brief. -1147.5. What is the difference between the HFC emissions (in thousand metric tons of CO2 equivalent) in 2005 and HFC emissions (in thousand metric tons of CO2 equivalent) in 2008 in Singapore?
Ensure brevity in your answer.  -446.7. What is the difference between the HFC emissions (in thousand metric tons of CO2 equivalent) of 1990 and HFC emissions (in thousand metric tons of CO2 equivalent) of 2000 in South Africa?
Ensure brevity in your answer.  -254.4. What is the difference between the HFC emissions (in thousand metric tons of CO2 equivalent) of 1990 and HFC emissions (in thousand metric tons of CO2 equivalent) of 2005 in South Africa?
Offer a very short reply. -524.3. What is the difference between the HFC emissions (in thousand metric tons of CO2 equivalent) of 1990 and HFC emissions (in thousand metric tons of CO2 equivalent) of 2008 in South Africa?
Your answer should be compact. -691.4. What is the difference between the HFC emissions (in thousand metric tons of CO2 equivalent) in 2000 and HFC emissions (in thousand metric tons of CO2 equivalent) in 2005 in South Africa?
Give a very brief answer. -269.9. What is the difference between the HFC emissions (in thousand metric tons of CO2 equivalent) in 2000 and HFC emissions (in thousand metric tons of CO2 equivalent) in 2008 in South Africa?
Your answer should be compact. -437. What is the difference between the HFC emissions (in thousand metric tons of CO2 equivalent) in 2005 and HFC emissions (in thousand metric tons of CO2 equivalent) in 2008 in South Africa?
Offer a terse response. -167.1. What is the ratio of the HFC emissions (in thousand metric tons of CO2 equivalent) of 1990 in Portugal to that in Russian Federation?
Your answer should be compact. 0. What is the ratio of the HFC emissions (in thousand metric tons of CO2 equivalent) of 2000 in Portugal to that in Russian Federation?
Offer a very short reply. 0.02. What is the ratio of the HFC emissions (in thousand metric tons of CO2 equivalent) of 2005 in Portugal to that in Russian Federation?
Provide a succinct answer. 0.03. What is the ratio of the HFC emissions (in thousand metric tons of CO2 equivalent) in 2008 in Portugal to that in Russian Federation?
Make the answer very short. 0.03. What is the ratio of the HFC emissions (in thousand metric tons of CO2 equivalent) of 1990 in Portugal to that in Saudi Arabia?
Ensure brevity in your answer.  2. What is the ratio of the HFC emissions (in thousand metric tons of CO2 equivalent) in 2000 in Portugal to that in Saudi Arabia?
Your answer should be very brief. 4.67. What is the ratio of the HFC emissions (in thousand metric tons of CO2 equivalent) of 2005 in Portugal to that in Saudi Arabia?
Ensure brevity in your answer.  3.29. What is the ratio of the HFC emissions (in thousand metric tons of CO2 equivalent) in 2008 in Portugal to that in Saudi Arabia?
Keep it short and to the point. 3.21. What is the ratio of the HFC emissions (in thousand metric tons of CO2 equivalent) of 2000 in Portugal to that in Serbia?
Make the answer very short. 0.21. What is the ratio of the HFC emissions (in thousand metric tons of CO2 equivalent) in 2005 in Portugal to that in Serbia?
Make the answer very short. 0.15. What is the ratio of the HFC emissions (in thousand metric tons of CO2 equivalent) of 2008 in Portugal to that in Serbia?
Ensure brevity in your answer.  0.14. What is the ratio of the HFC emissions (in thousand metric tons of CO2 equivalent) of 1990 in Portugal to that in Singapore?
Make the answer very short. 0.02. What is the ratio of the HFC emissions (in thousand metric tons of CO2 equivalent) of 2000 in Portugal to that in Singapore?
Provide a short and direct response. 0.48. What is the ratio of the HFC emissions (in thousand metric tons of CO2 equivalent) in 2005 in Portugal to that in Singapore?
Your response must be concise. 0.45. What is the ratio of the HFC emissions (in thousand metric tons of CO2 equivalent) in 2008 in Portugal to that in Singapore?
Provide a succinct answer. 0.46. What is the ratio of the HFC emissions (in thousand metric tons of CO2 equivalent) in 2000 in Portugal to that in South Africa?
Your response must be concise. 1.39. What is the ratio of the HFC emissions (in thousand metric tons of CO2 equivalent) in 2005 in Portugal to that in South Africa?
Ensure brevity in your answer.  1.23. What is the ratio of the HFC emissions (in thousand metric tons of CO2 equivalent) of 2008 in Portugal to that in South Africa?
Keep it short and to the point. 1.24. What is the ratio of the HFC emissions (in thousand metric tons of CO2 equivalent) of 1990 in Russian Federation to that in Saudi Arabia?
Your answer should be compact. 5.04e+04. What is the ratio of the HFC emissions (in thousand metric tons of CO2 equivalent) in 2000 in Russian Federation to that in Saudi Arabia?
Provide a short and direct response. 222.37. What is the ratio of the HFC emissions (in thousand metric tons of CO2 equivalent) of 2005 in Russian Federation to that in Saudi Arabia?
Provide a succinct answer. 123.06. What is the ratio of the HFC emissions (in thousand metric tons of CO2 equivalent) in 2008 in Russian Federation to that in Saudi Arabia?
Your answer should be compact. 107.41. What is the ratio of the HFC emissions (in thousand metric tons of CO2 equivalent) of 1990 in Russian Federation to that in Serbia?
Offer a terse response. 1.01e+04. What is the ratio of the HFC emissions (in thousand metric tons of CO2 equivalent) in 2000 in Russian Federation to that in Serbia?
Ensure brevity in your answer.  10.1. What is the ratio of the HFC emissions (in thousand metric tons of CO2 equivalent) in 2005 in Russian Federation to that in Serbia?
Give a very brief answer. 5.64. What is the ratio of the HFC emissions (in thousand metric tons of CO2 equivalent) in 2008 in Russian Federation to that in Serbia?
Keep it short and to the point. 4.79. What is the ratio of the HFC emissions (in thousand metric tons of CO2 equivalent) in 1990 in Russian Federation to that in Singapore?
Make the answer very short. 399.65. What is the ratio of the HFC emissions (in thousand metric tons of CO2 equivalent) of 2000 in Russian Federation to that in Singapore?
Your answer should be very brief. 23.03. What is the ratio of the HFC emissions (in thousand metric tons of CO2 equivalent) in 2005 in Russian Federation to that in Singapore?
Keep it short and to the point. 16.95. What is the ratio of the HFC emissions (in thousand metric tons of CO2 equivalent) in 2008 in Russian Federation to that in Singapore?
Your answer should be compact. 15.25. What is the ratio of the HFC emissions (in thousand metric tons of CO2 equivalent) of 1990 in Russian Federation to that in South Africa?
Provide a succinct answer. 2.52e+04. What is the ratio of the HFC emissions (in thousand metric tons of CO2 equivalent) of 2000 in Russian Federation to that in South Africa?
Offer a very short reply. 65.94. What is the ratio of the HFC emissions (in thousand metric tons of CO2 equivalent) of 2005 in Russian Federation to that in South Africa?
Your response must be concise. 46.2. What is the ratio of the HFC emissions (in thousand metric tons of CO2 equivalent) in 2008 in Russian Federation to that in South Africa?
Offer a very short reply. 41.39. What is the ratio of the HFC emissions (in thousand metric tons of CO2 equivalent) in 2000 in Saudi Arabia to that in Serbia?
Make the answer very short. 0.05. What is the ratio of the HFC emissions (in thousand metric tons of CO2 equivalent) in 2005 in Saudi Arabia to that in Serbia?
Keep it short and to the point. 0.05. What is the ratio of the HFC emissions (in thousand metric tons of CO2 equivalent) in 2008 in Saudi Arabia to that in Serbia?
Make the answer very short. 0.04. What is the ratio of the HFC emissions (in thousand metric tons of CO2 equivalent) in 1990 in Saudi Arabia to that in Singapore?
Provide a short and direct response. 0.01. What is the ratio of the HFC emissions (in thousand metric tons of CO2 equivalent) of 2000 in Saudi Arabia to that in Singapore?
Offer a very short reply. 0.1. What is the ratio of the HFC emissions (in thousand metric tons of CO2 equivalent) in 2005 in Saudi Arabia to that in Singapore?
Keep it short and to the point. 0.14. What is the ratio of the HFC emissions (in thousand metric tons of CO2 equivalent) in 2008 in Saudi Arabia to that in Singapore?
Your response must be concise. 0.14. What is the ratio of the HFC emissions (in thousand metric tons of CO2 equivalent) in 2000 in Saudi Arabia to that in South Africa?
Ensure brevity in your answer.  0.3. What is the ratio of the HFC emissions (in thousand metric tons of CO2 equivalent) in 2005 in Saudi Arabia to that in South Africa?
Give a very brief answer. 0.38. What is the ratio of the HFC emissions (in thousand metric tons of CO2 equivalent) of 2008 in Saudi Arabia to that in South Africa?
Offer a terse response. 0.39. What is the ratio of the HFC emissions (in thousand metric tons of CO2 equivalent) in 1990 in Serbia to that in Singapore?
Offer a very short reply. 0.04. What is the ratio of the HFC emissions (in thousand metric tons of CO2 equivalent) of 2000 in Serbia to that in Singapore?
Provide a succinct answer. 2.28. What is the ratio of the HFC emissions (in thousand metric tons of CO2 equivalent) of 2005 in Serbia to that in Singapore?
Give a very brief answer. 3. What is the ratio of the HFC emissions (in thousand metric tons of CO2 equivalent) of 2008 in Serbia to that in Singapore?
Offer a very short reply. 3.19. What is the ratio of the HFC emissions (in thousand metric tons of CO2 equivalent) in 2000 in Serbia to that in South Africa?
Your response must be concise. 6.53. What is the ratio of the HFC emissions (in thousand metric tons of CO2 equivalent) in 2005 in Serbia to that in South Africa?
Your answer should be compact. 8.19. What is the ratio of the HFC emissions (in thousand metric tons of CO2 equivalent) of 2008 in Serbia to that in South Africa?
Give a very brief answer. 8.65. What is the ratio of the HFC emissions (in thousand metric tons of CO2 equivalent) of 1990 in Singapore to that in South Africa?
Your answer should be very brief. 63. What is the ratio of the HFC emissions (in thousand metric tons of CO2 equivalent) in 2000 in Singapore to that in South Africa?
Offer a very short reply. 2.86. What is the ratio of the HFC emissions (in thousand metric tons of CO2 equivalent) in 2005 in Singapore to that in South Africa?
Your response must be concise. 2.73. What is the ratio of the HFC emissions (in thousand metric tons of CO2 equivalent) in 2008 in Singapore to that in South Africa?
Your answer should be very brief. 2.71. What is the difference between the highest and the second highest HFC emissions (in thousand metric tons of CO2 equivalent) of 1990?
Your answer should be very brief. 5023. What is the difference between the highest and the second highest HFC emissions (in thousand metric tons of CO2 equivalent) of 2000?
Offer a terse response. 1.51e+04. What is the difference between the highest and the second highest HFC emissions (in thousand metric tons of CO2 equivalent) in 2005?
Provide a short and direct response. 1.99e+04. What is the difference between the highest and the second highest HFC emissions (in thousand metric tons of CO2 equivalent) of 2008?
Provide a succinct answer. 2.26e+04. What is the difference between the highest and the lowest HFC emissions (in thousand metric tons of CO2 equivalent) of 1990?
Your answer should be very brief. 5035.5. What is the difference between the highest and the lowest HFC emissions (in thousand metric tons of CO2 equivalent) of 2000?
Give a very brief answer. 1.67e+04. What is the difference between the highest and the lowest HFC emissions (in thousand metric tons of CO2 equivalent) in 2005?
Provide a succinct answer. 2.40e+04. What is the difference between the highest and the lowest HFC emissions (in thousand metric tons of CO2 equivalent) in 2008?
Offer a very short reply. 2.84e+04. 